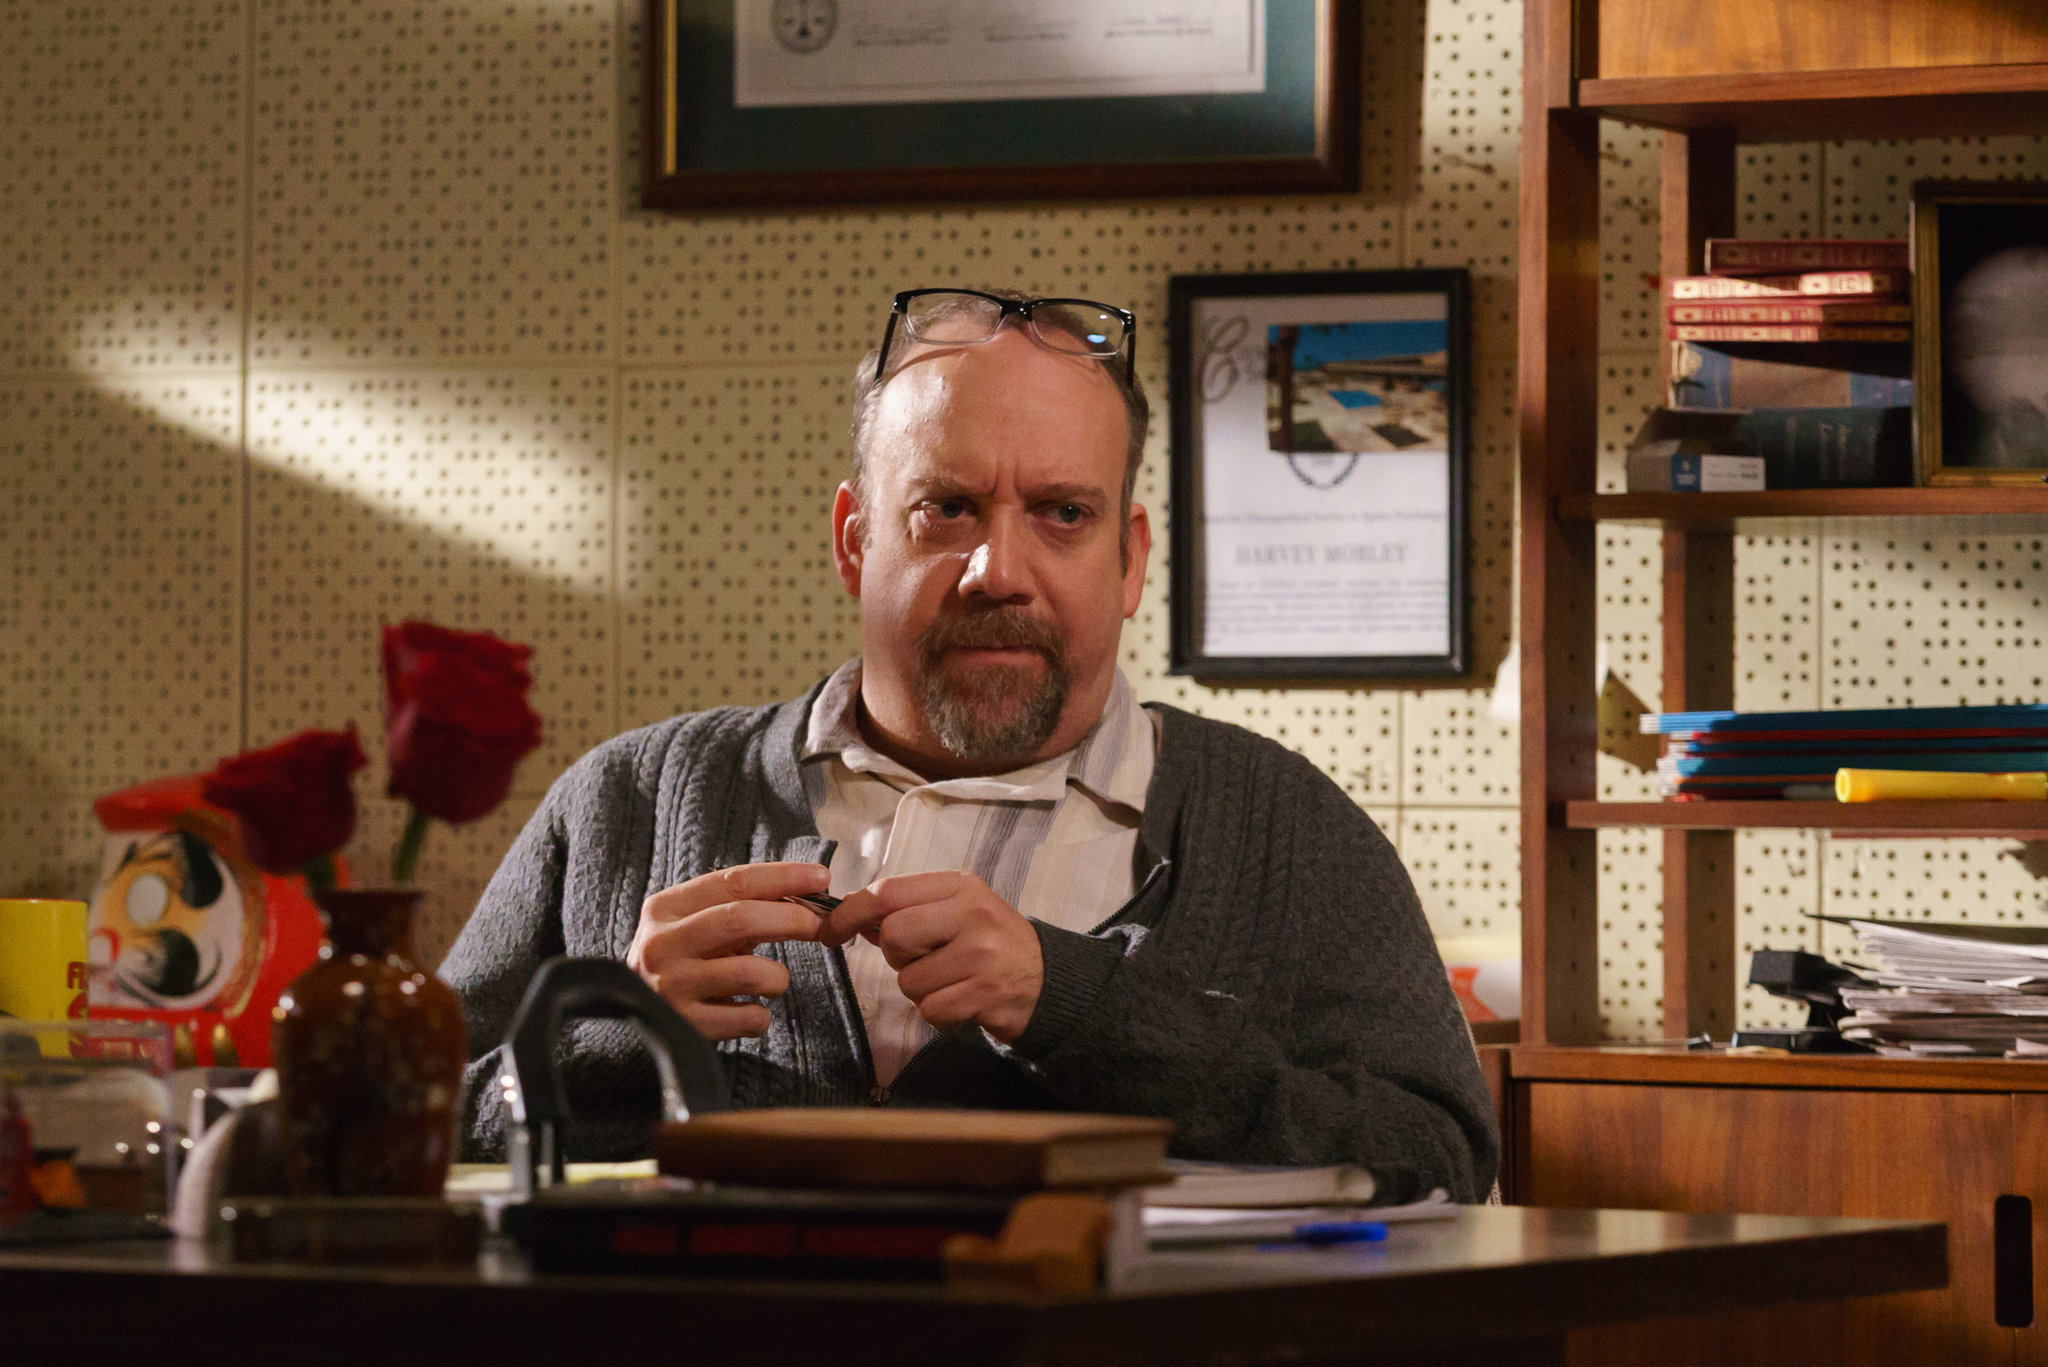What emotions do you think the man in the image is experiencing, and why? The man in the image appears to be experiencing deep concentration and perhaps a sense of determination. His serious expression, combined with the focused look in his eyes as he gazes directly at the camera, suggests he is deeply absorbed in his thoughts or work. The cluttered desk filled with papers and books indicates that he might be dealing with a heavy workload or a complex problem, engendering feelings of responsibility and intensity. 